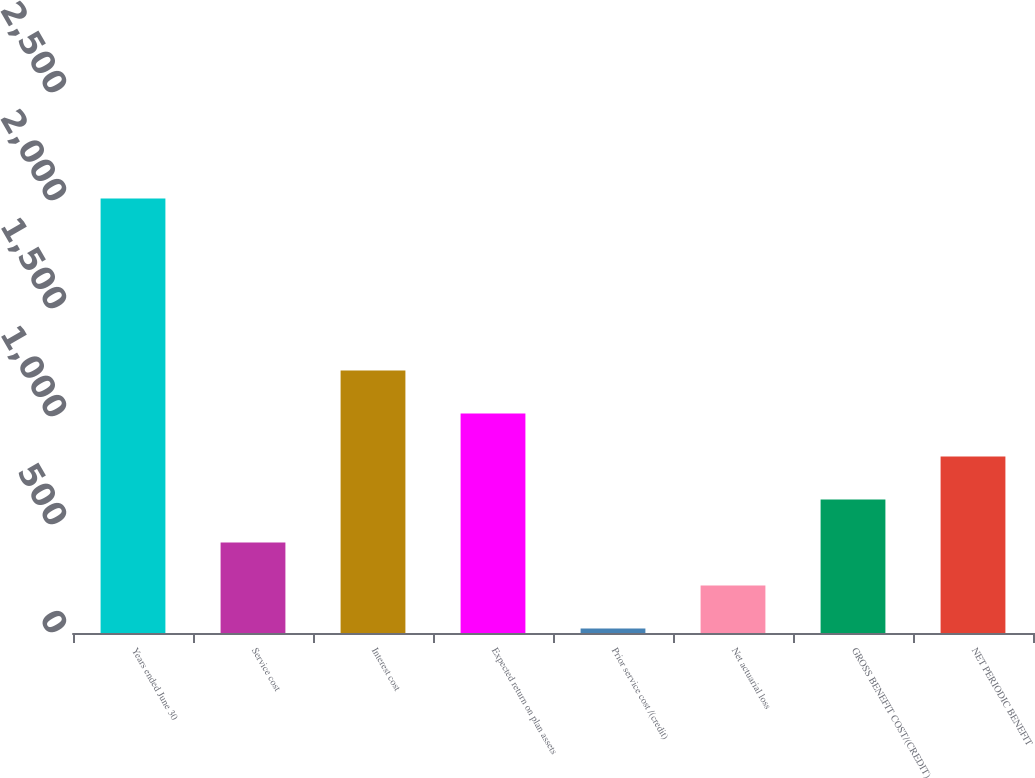Convert chart. <chart><loc_0><loc_0><loc_500><loc_500><bar_chart><fcel>Years ended June 30<fcel>Service cost<fcel>Interest cost<fcel>Expected return on plan assets<fcel>Prior service cost /(credit)<fcel>Net actuarial loss<fcel>GROSS BENEFIT COST/(CREDIT)<fcel>NET PERIODIC BENEFIT<nl><fcel>2012<fcel>419.2<fcel>1215.6<fcel>1016.5<fcel>21<fcel>220.1<fcel>618.3<fcel>817.4<nl></chart> 